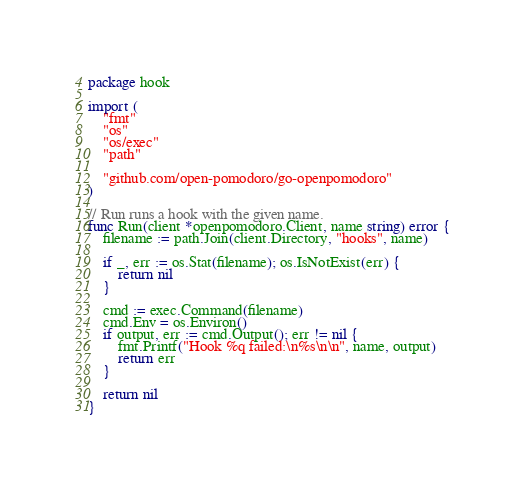<code> <loc_0><loc_0><loc_500><loc_500><_Go_>package hook

import (
	"fmt"
	"os"
	"os/exec"
	"path"

	"github.com/open-pomodoro/go-openpomodoro"
)

// Run runs a hook with the given name.
func Run(client *openpomodoro.Client, name string) error {
	filename := path.Join(client.Directory, "hooks", name)

	if _, err := os.Stat(filename); os.IsNotExist(err) {
		return nil
	}

	cmd := exec.Command(filename)
	cmd.Env = os.Environ()
	if output, err := cmd.Output(); err != nil {
		fmt.Printf("Hook %q failed:\n%s\n\n", name, output)
		return err
	}

	return nil
}
</code> 